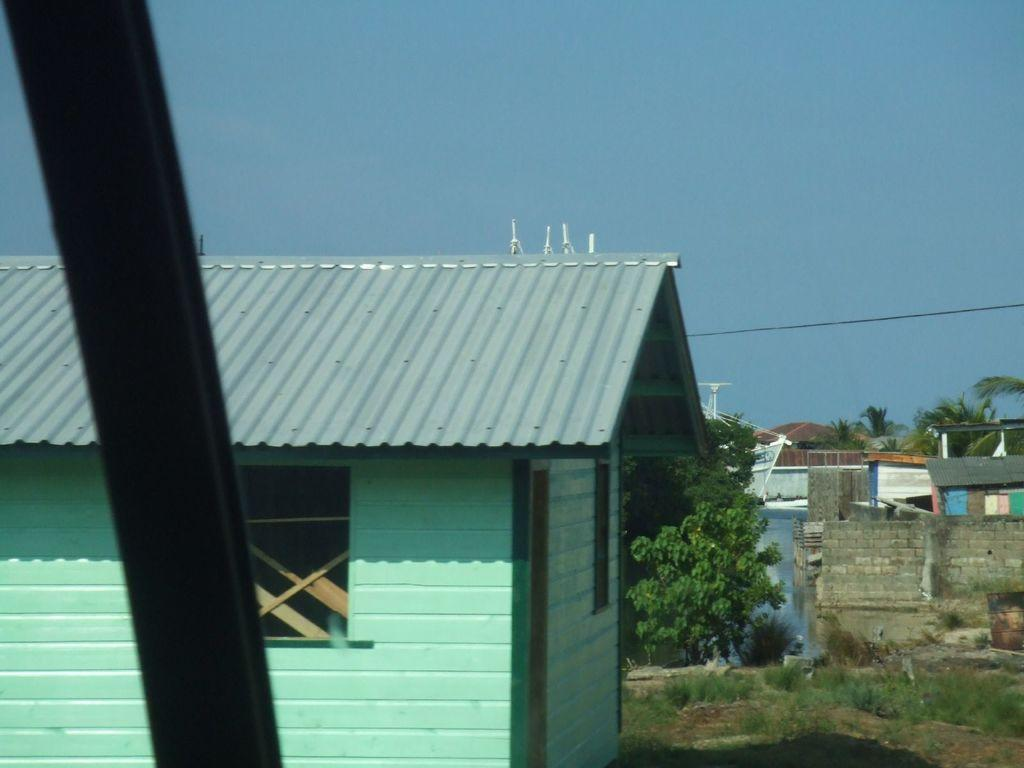What type of structures can be seen in the image? There are many houses in the image. What is the purpose of the wall in the image? The wall in the image serves as a boundary or divider. What type of vegetation is present in the image? There are trees in the image. What is the ground covered with in the image? The ground is covered with grass in the image. What can be seen in the background of the image? The sky is plain and visible in the background of the image. Where is the train located in the image? There is no train present in the image. What type of glue is used to hold the houses together in the image? The houses in the image are not held together by glue; they are separate structures. 